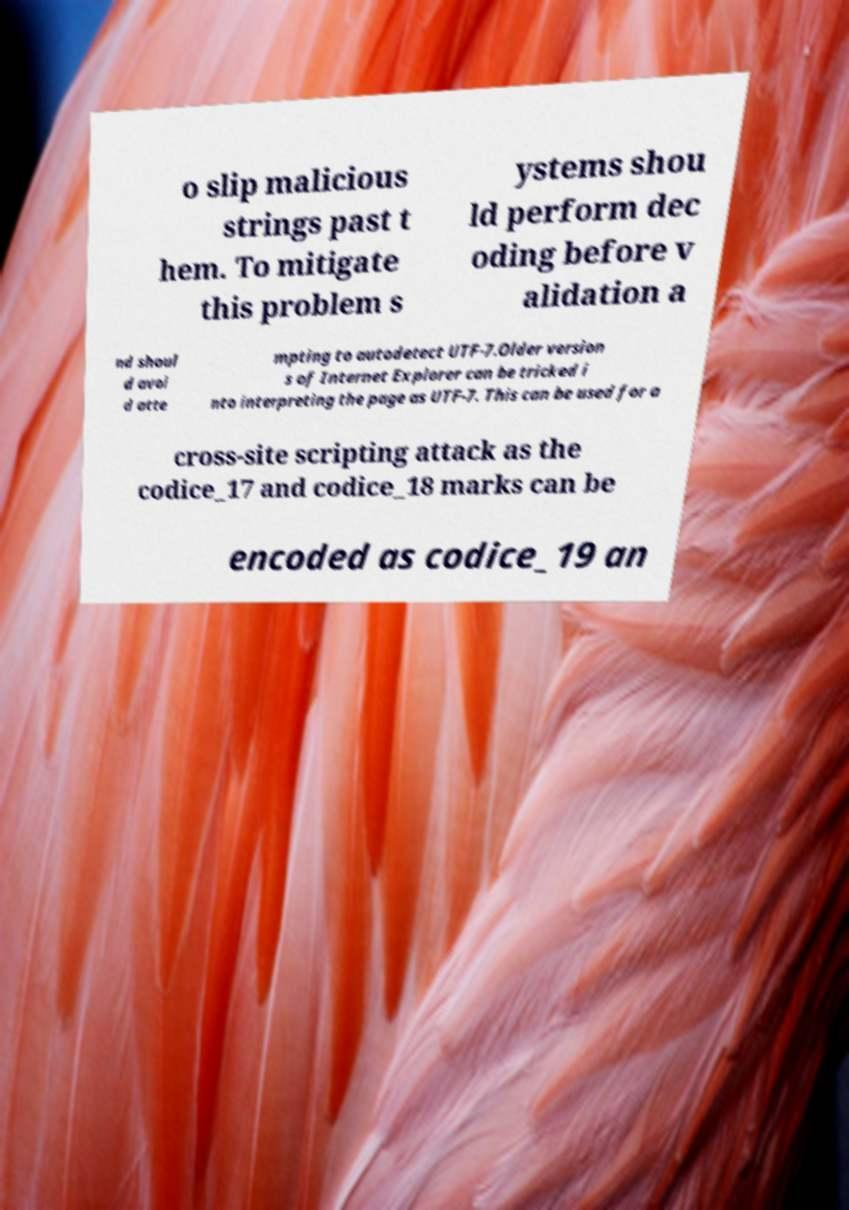I need the written content from this picture converted into text. Can you do that? o slip malicious strings past t hem. To mitigate this problem s ystems shou ld perform dec oding before v alidation a nd shoul d avoi d atte mpting to autodetect UTF-7.Older version s of Internet Explorer can be tricked i nto interpreting the page as UTF-7. This can be used for a cross-site scripting attack as the codice_17 and codice_18 marks can be encoded as codice_19 an 